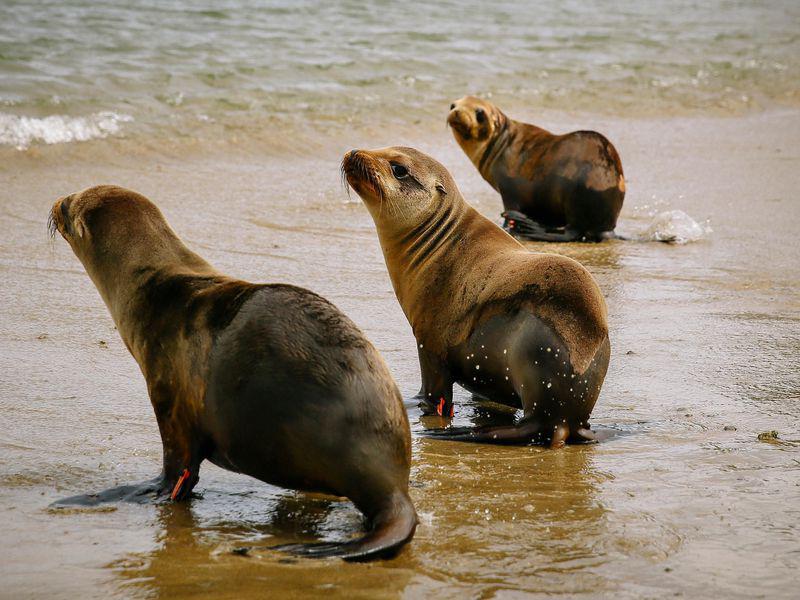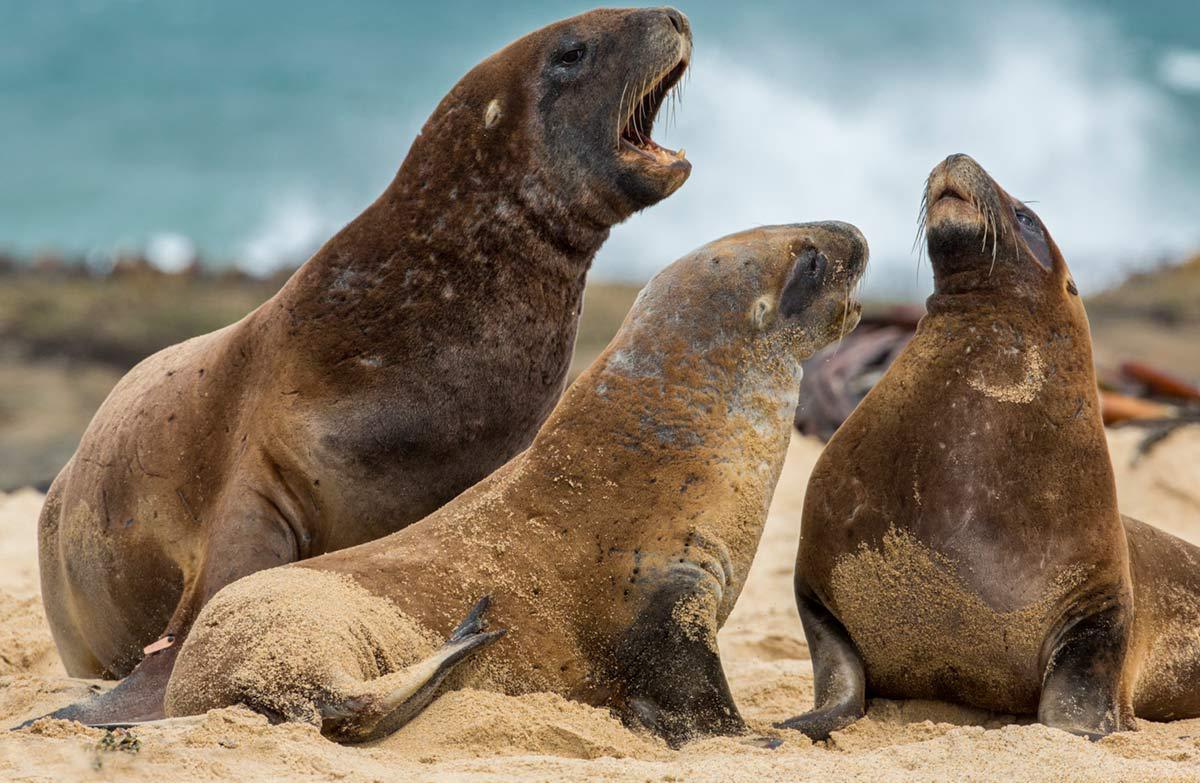The first image is the image on the left, the second image is the image on the right. For the images shown, is this caption "There are no more than five sea animals on the shore." true? Answer yes or no. No. The first image is the image on the left, the second image is the image on the right. Evaluate the accuracy of this statement regarding the images: "An image shows exactly two seals, both with their mouths opened.". Is it true? Answer yes or no. No. The first image is the image on the left, the second image is the image on the right. Given the left and right images, does the statement "The photo on the right contains three or more animals." hold true? Answer yes or no. Yes. The first image is the image on the left, the second image is the image on the right. Assess this claim about the two images: "Right and left image contain the same number of seals.". Correct or not? Answer yes or no. Yes. 